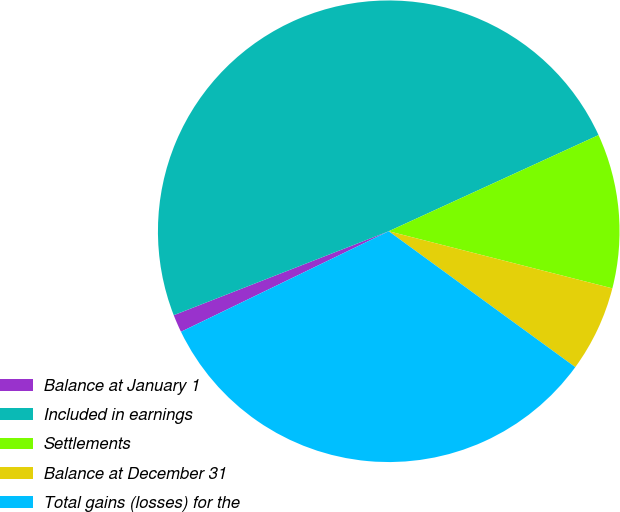<chart> <loc_0><loc_0><loc_500><loc_500><pie_chart><fcel>Balance at January 1<fcel>Included in earnings<fcel>Settlements<fcel>Balance at December 31<fcel>Total gains (losses) for the<nl><fcel>1.25%<fcel>49.09%<fcel>10.82%<fcel>6.04%<fcel>32.81%<nl></chart> 